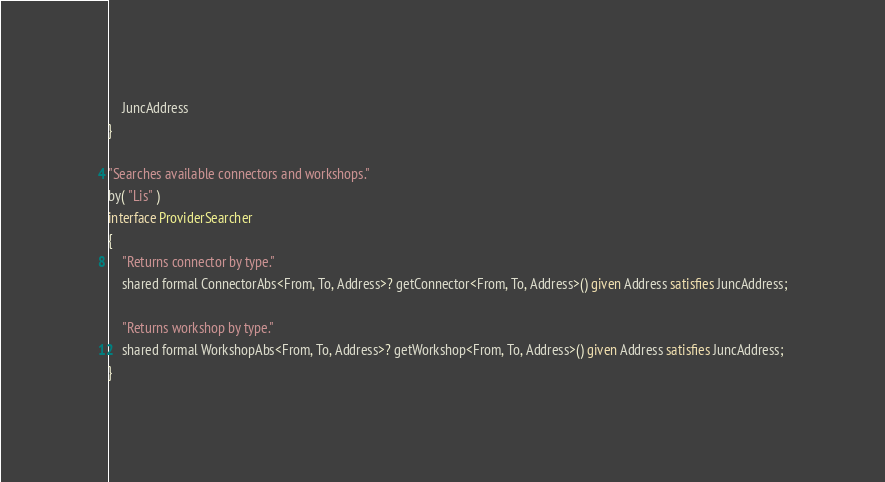Convert code to text. <code><loc_0><loc_0><loc_500><loc_500><_Ceylon_>
	JuncAddress
}

"Searches available connectors and workshops."
by( "Lis" )
interface ProviderSearcher
{
	"Returns connector by type."
	shared formal ConnectorAbs<From, To, Address>? getConnector<From, To, Address>() given Address satisfies JuncAddress;
	
	"Returns workshop by type."
	shared formal WorkshopAbs<From, To, Address>? getWorkshop<From, To, Address>() given Address satisfies JuncAddress;
}
</code> 